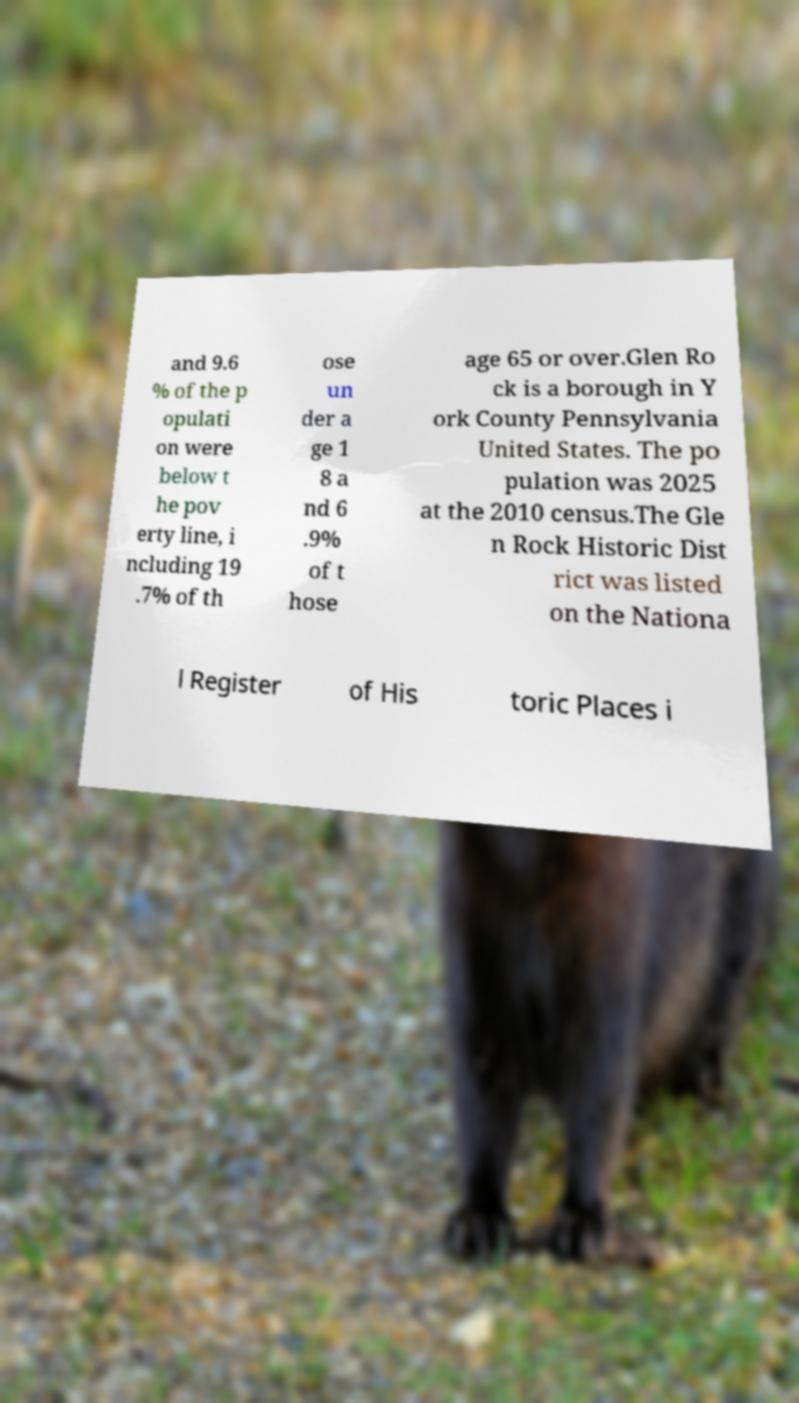Please identify and transcribe the text found in this image. and 9.6 % of the p opulati on were below t he pov erty line, i ncluding 19 .7% of th ose un der a ge 1 8 a nd 6 .9% of t hose age 65 or over.Glen Ro ck is a borough in Y ork County Pennsylvania United States. The po pulation was 2025 at the 2010 census.The Gle n Rock Historic Dist rict was listed on the Nationa l Register of His toric Places i 